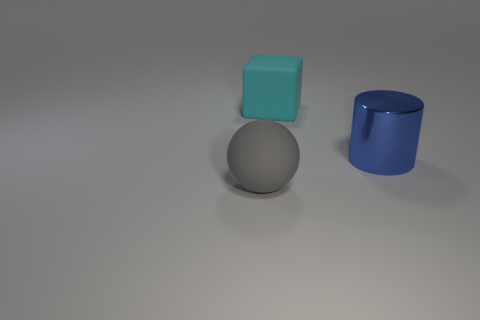Add 3 blue things. How many objects exist? 6 Subtract all spheres. How many objects are left? 2 Add 3 big metal cylinders. How many big metal cylinders are left? 4 Add 1 tiny red rubber cylinders. How many tiny red rubber cylinders exist? 1 Subtract 1 gray spheres. How many objects are left? 2 Subtract all small blue metallic things. Subtract all blocks. How many objects are left? 2 